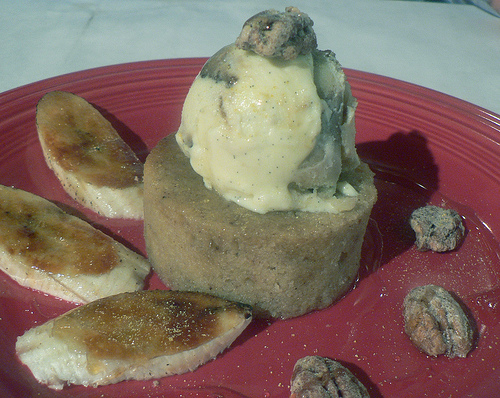<image>
Is there a mashed potatoes on the plate? No. The mashed potatoes is not positioned on the plate. They may be near each other, but the mashed potatoes is not supported by or resting on top of the plate. 